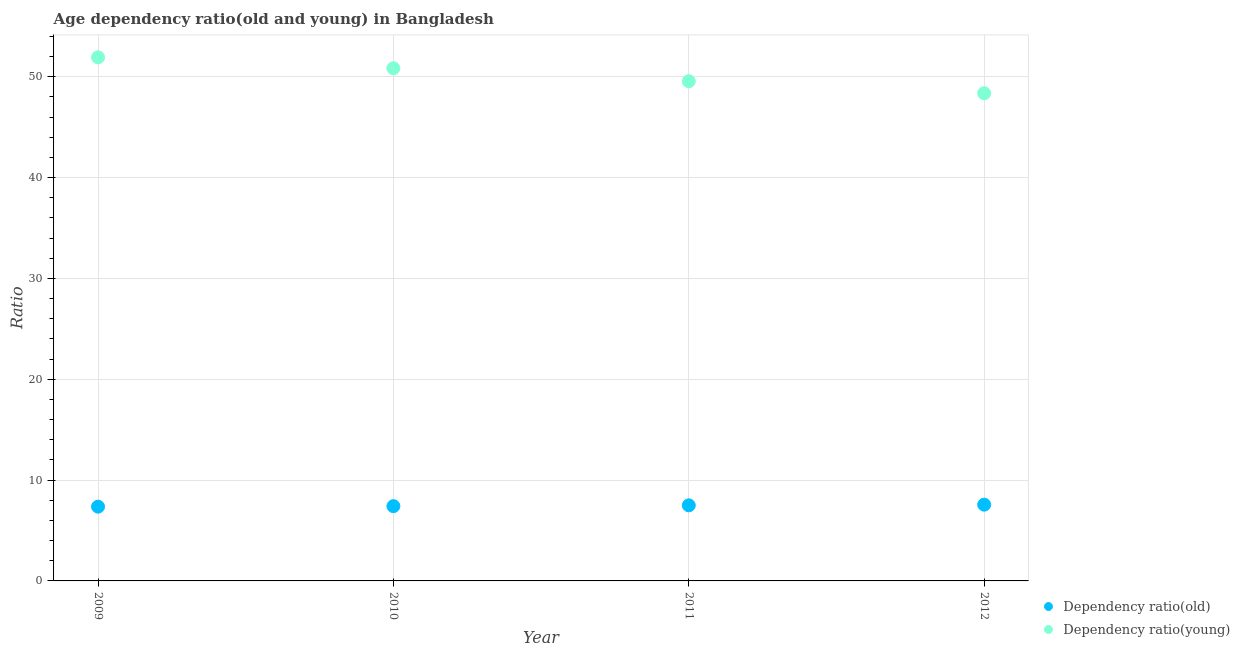Is the number of dotlines equal to the number of legend labels?
Offer a terse response. Yes. What is the age dependency ratio(old) in 2011?
Give a very brief answer. 7.5. Across all years, what is the maximum age dependency ratio(old)?
Ensure brevity in your answer.  7.56. Across all years, what is the minimum age dependency ratio(young)?
Give a very brief answer. 48.37. In which year was the age dependency ratio(old) minimum?
Your response must be concise. 2009. What is the total age dependency ratio(young) in the graph?
Your answer should be compact. 200.71. What is the difference between the age dependency ratio(old) in 2011 and that in 2012?
Offer a terse response. -0.07. What is the difference between the age dependency ratio(young) in 2012 and the age dependency ratio(old) in 2009?
Offer a terse response. 41. What is the average age dependency ratio(young) per year?
Offer a very short reply. 50.18. In the year 2011, what is the difference between the age dependency ratio(young) and age dependency ratio(old)?
Ensure brevity in your answer.  42.07. In how many years, is the age dependency ratio(old) greater than 14?
Give a very brief answer. 0. What is the ratio of the age dependency ratio(old) in 2009 to that in 2010?
Your response must be concise. 0.99. Is the age dependency ratio(young) in 2009 less than that in 2012?
Ensure brevity in your answer.  No. Is the difference between the age dependency ratio(old) in 2010 and 2012 greater than the difference between the age dependency ratio(young) in 2010 and 2012?
Offer a terse response. No. What is the difference between the highest and the second highest age dependency ratio(young)?
Provide a short and direct response. 1.08. What is the difference between the highest and the lowest age dependency ratio(young)?
Offer a very short reply. 3.56. In how many years, is the age dependency ratio(young) greater than the average age dependency ratio(young) taken over all years?
Your response must be concise. 2. Is the sum of the age dependency ratio(old) in 2009 and 2011 greater than the maximum age dependency ratio(young) across all years?
Give a very brief answer. No. Does the age dependency ratio(old) monotonically increase over the years?
Your answer should be compact. Yes. Is the age dependency ratio(young) strictly greater than the age dependency ratio(old) over the years?
Your answer should be compact. Yes. How many dotlines are there?
Ensure brevity in your answer.  2. How many years are there in the graph?
Make the answer very short. 4. What is the difference between two consecutive major ticks on the Y-axis?
Your answer should be very brief. 10. Does the graph contain any zero values?
Offer a terse response. No. Where does the legend appear in the graph?
Ensure brevity in your answer.  Bottom right. How many legend labels are there?
Your answer should be very brief. 2. What is the title of the graph?
Offer a terse response. Age dependency ratio(old and young) in Bangladesh. What is the label or title of the X-axis?
Your answer should be very brief. Year. What is the label or title of the Y-axis?
Your answer should be very brief. Ratio. What is the Ratio in Dependency ratio(old) in 2009?
Ensure brevity in your answer.  7.37. What is the Ratio of Dependency ratio(young) in 2009?
Offer a terse response. 51.93. What is the Ratio of Dependency ratio(old) in 2010?
Your answer should be very brief. 7.42. What is the Ratio of Dependency ratio(young) in 2010?
Your answer should be compact. 50.85. What is the Ratio of Dependency ratio(old) in 2011?
Give a very brief answer. 7.5. What is the Ratio of Dependency ratio(young) in 2011?
Offer a terse response. 49.56. What is the Ratio in Dependency ratio(old) in 2012?
Ensure brevity in your answer.  7.56. What is the Ratio in Dependency ratio(young) in 2012?
Provide a short and direct response. 48.37. Across all years, what is the maximum Ratio of Dependency ratio(old)?
Keep it short and to the point. 7.56. Across all years, what is the maximum Ratio of Dependency ratio(young)?
Provide a short and direct response. 51.93. Across all years, what is the minimum Ratio in Dependency ratio(old)?
Keep it short and to the point. 7.37. Across all years, what is the minimum Ratio of Dependency ratio(young)?
Offer a very short reply. 48.37. What is the total Ratio in Dependency ratio(old) in the graph?
Offer a terse response. 29.84. What is the total Ratio in Dependency ratio(young) in the graph?
Your response must be concise. 200.71. What is the difference between the Ratio of Dependency ratio(old) in 2009 and that in 2010?
Give a very brief answer. -0.05. What is the difference between the Ratio in Dependency ratio(young) in 2009 and that in 2010?
Give a very brief answer. 1.08. What is the difference between the Ratio in Dependency ratio(old) in 2009 and that in 2011?
Offer a terse response. -0.13. What is the difference between the Ratio in Dependency ratio(young) in 2009 and that in 2011?
Ensure brevity in your answer.  2.37. What is the difference between the Ratio of Dependency ratio(old) in 2009 and that in 2012?
Offer a terse response. -0.2. What is the difference between the Ratio of Dependency ratio(young) in 2009 and that in 2012?
Your response must be concise. 3.56. What is the difference between the Ratio in Dependency ratio(old) in 2010 and that in 2011?
Your answer should be compact. -0.08. What is the difference between the Ratio in Dependency ratio(young) in 2010 and that in 2011?
Your answer should be very brief. 1.28. What is the difference between the Ratio in Dependency ratio(old) in 2010 and that in 2012?
Offer a terse response. -0.15. What is the difference between the Ratio of Dependency ratio(young) in 2010 and that in 2012?
Make the answer very short. 2.48. What is the difference between the Ratio of Dependency ratio(old) in 2011 and that in 2012?
Give a very brief answer. -0.07. What is the difference between the Ratio of Dependency ratio(young) in 2011 and that in 2012?
Give a very brief answer. 1.2. What is the difference between the Ratio of Dependency ratio(old) in 2009 and the Ratio of Dependency ratio(young) in 2010?
Provide a succinct answer. -43.48. What is the difference between the Ratio of Dependency ratio(old) in 2009 and the Ratio of Dependency ratio(young) in 2011?
Your response must be concise. -42.2. What is the difference between the Ratio of Dependency ratio(old) in 2009 and the Ratio of Dependency ratio(young) in 2012?
Provide a short and direct response. -41. What is the difference between the Ratio in Dependency ratio(old) in 2010 and the Ratio in Dependency ratio(young) in 2011?
Your answer should be compact. -42.15. What is the difference between the Ratio of Dependency ratio(old) in 2010 and the Ratio of Dependency ratio(young) in 2012?
Keep it short and to the point. -40.95. What is the difference between the Ratio of Dependency ratio(old) in 2011 and the Ratio of Dependency ratio(young) in 2012?
Provide a short and direct response. -40.87. What is the average Ratio of Dependency ratio(old) per year?
Ensure brevity in your answer.  7.46. What is the average Ratio in Dependency ratio(young) per year?
Make the answer very short. 50.18. In the year 2009, what is the difference between the Ratio in Dependency ratio(old) and Ratio in Dependency ratio(young)?
Ensure brevity in your answer.  -44.56. In the year 2010, what is the difference between the Ratio of Dependency ratio(old) and Ratio of Dependency ratio(young)?
Give a very brief answer. -43.43. In the year 2011, what is the difference between the Ratio of Dependency ratio(old) and Ratio of Dependency ratio(young)?
Keep it short and to the point. -42.07. In the year 2012, what is the difference between the Ratio of Dependency ratio(old) and Ratio of Dependency ratio(young)?
Ensure brevity in your answer.  -40.8. What is the ratio of the Ratio of Dependency ratio(old) in 2009 to that in 2010?
Offer a terse response. 0.99. What is the ratio of the Ratio of Dependency ratio(young) in 2009 to that in 2010?
Your response must be concise. 1.02. What is the ratio of the Ratio in Dependency ratio(old) in 2009 to that in 2011?
Give a very brief answer. 0.98. What is the ratio of the Ratio in Dependency ratio(young) in 2009 to that in 2011?
Keep it short and to the point. 1.05. What is the ratio of the Ratio of Dependency ratio(old) in 2009 to that in 2012?
Ensure brevity in your answer.  0.97. What is the ratio of the Ratio in Dependency ratio(young) in 2009 to that in 2012?
Ensure brevity in your answer.  1.07. What is the ratio of the Ratio of Dependency ratio(old) in 2010 to that in 2011?
Offer a very short reply. 0.99. What is the ratio of the Ratio in Dependency ratio(young) in 2010 to that in 2011?
Offer a very short reply. 1.03. What is the ratio of the Ratio of Dependency ratio(old) in 2010 to that in 2012?
Keep it short and to the point. 0.98. What is the ratio of the Ratio of Dependency ratio(young) in 2010 to that in 2012?
Your answer should be compact. 1.05. What is the ratio of the Ratio in Dependency ratio(old) in 2011 to that in 2012?
Provide a short and direct response. 0.99. What is the ratio of the Ratio in Dependency ratio(young) in 2011 to that in 2012?
Make the answer very short. 1.02. What is the difference between the highest and the second highest Ratio of Dependency ratio(old)?
Your answer should be compact. 0.07. What is the difference between the highest and the second highest Ratio in Dependency ratio(young)?
Provide a succinct answer. 1.08. What is the difference between the highest and the lowest Ratio in Dependency ratio(old)?
Offer a very short reply. 0.2. What is the difference between the highest and the lowest Ratio in Dependency ratio(young)?
Give a very brief answer. 3.56. 